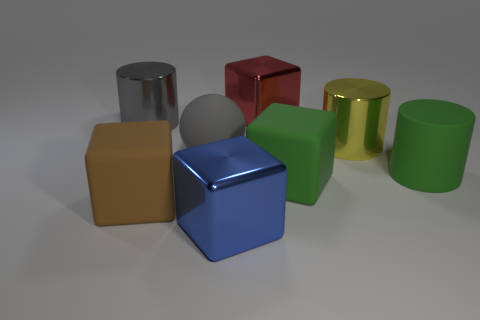What number of cylinders are behind the big shiny cube that is behind the large rubber cylinder?
Provide a short and direct response. 0. Is the number of metallic cubes that are on the left side of the brown cube less than the number of big brown metal cubes?
Offer a very short reply. No. Are there any gray matte objects left of the object behind the metal cylinder that is to the left of the brown rubber thing?
Make the answer very short. Yes. Do the green block and the cube that is behind the yellow object have the same material?
Make the answer very short. No. What color is the thing behind the big metallic thing that is left of the big blue shiny block?
Make the answer very short. Red. Is there a thing that has the same color as the rubber cylinder?
Your response must be concise. Yes. There is a cube behind the green object right of the big green matte thing that is in front of the big matte cylinder; what size is it?
Provide a succinct answer. Large. There is a big yellow metallic object; does it have the same shape as the large thing that is in front of the big brown matte block?
Offer a terse response. No. How many other things are there of the same size as the yellow cylinder?
Your response must be concise. 7. What size is the green rubber object behind the green block?
Ensure brevity in your answer.  Large. 